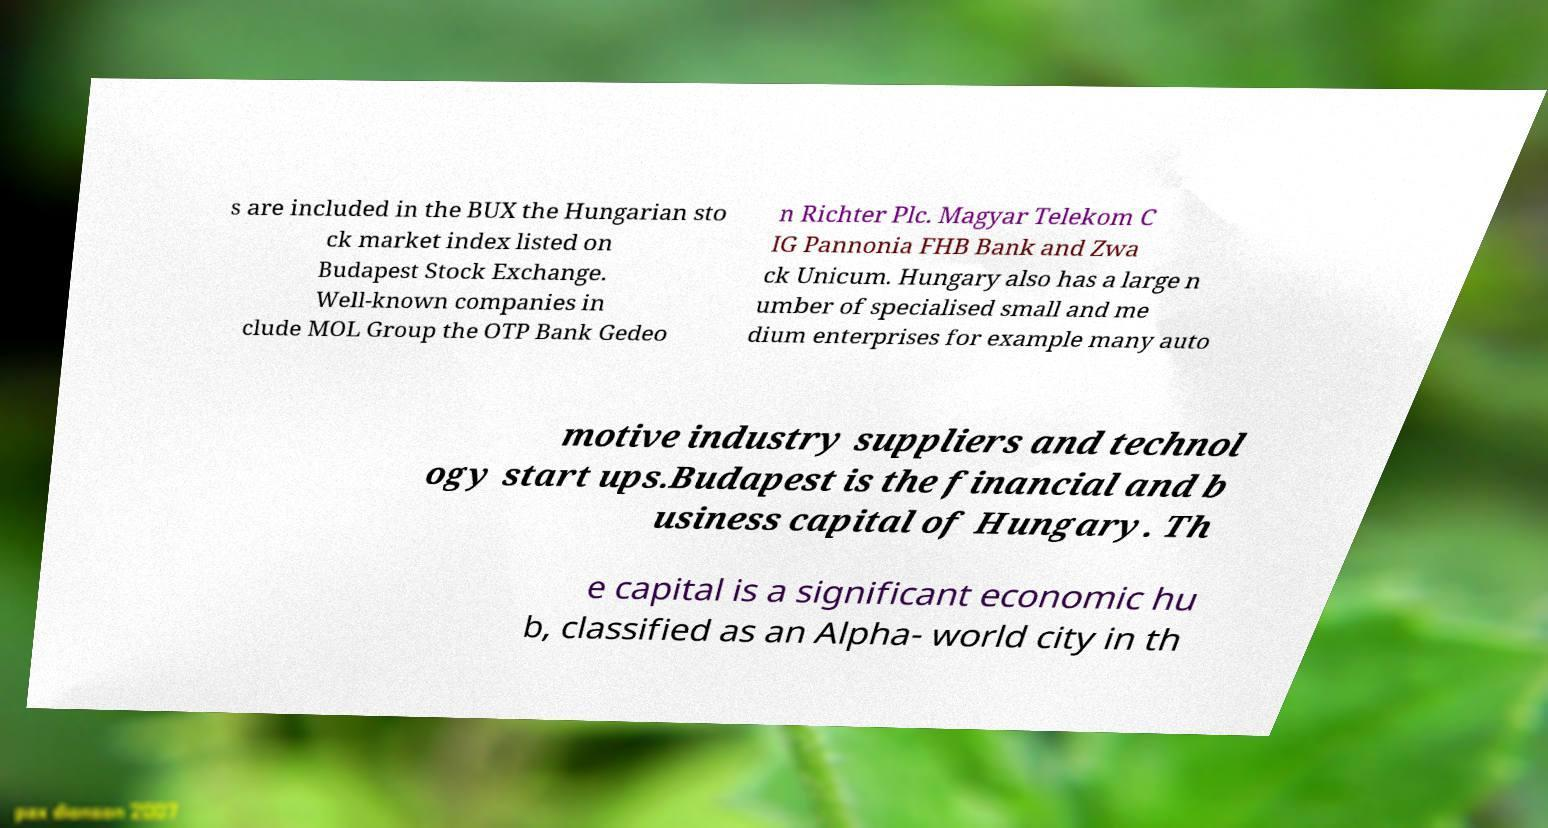Please read and relay the text visible in this image. What does it say? s are included in the BUX the Hungarian sto ck market index listed on Budapest Stock Exchange. Well-known companies in clude MOL Group the OTP Bank Gedeo n Richter Plc. Magyar Telekom C IG Pannonia FHB Bank and Zwa ck Unicum. Hungary also has a large n umber of specialised small and me dium enterprises for example many auto motive industry suppliers and technol ogy start ups.Budapest is the financial and b usiness capital of Hungary. Th e capital is a significant economic hu b, classified as an Alpha- world city in th 